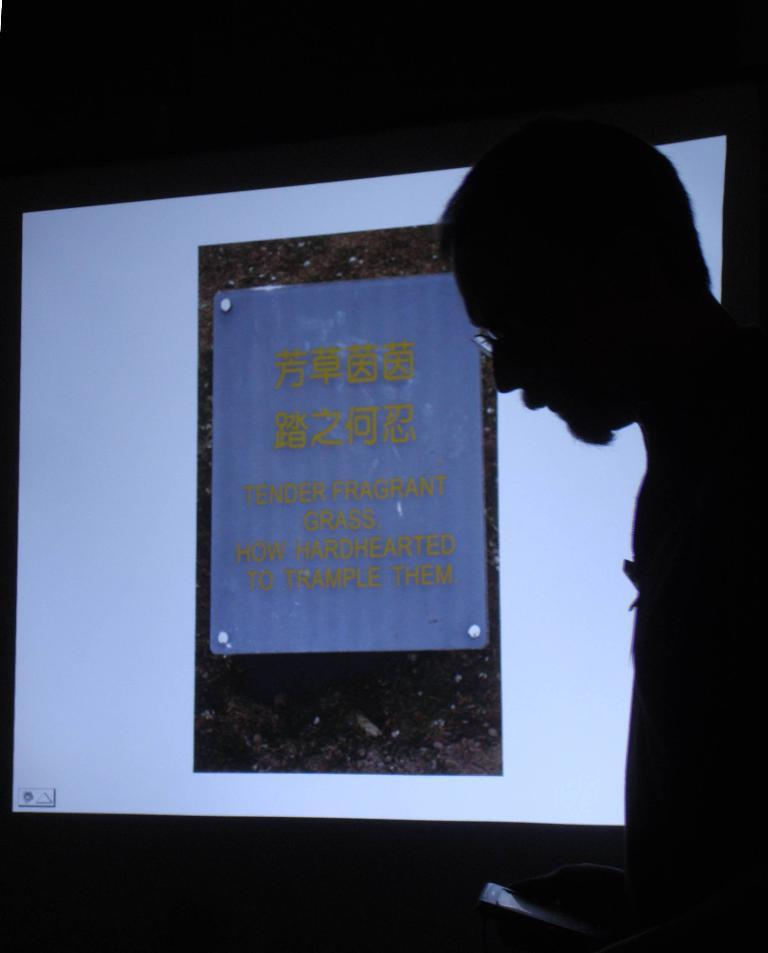What can be seen in the image? There is a person in the image. What is the person doing in the image? The person is holding an object. What can be seen in the background of the image? There is a poster with text in the background of the image. What type of berry is the person holding in the image? There is no berry present in the image; the person is holding an object. Can you describe the flight of the snakes in the image? There are no snakes present in the image, so it is not possible to describe their flight. 